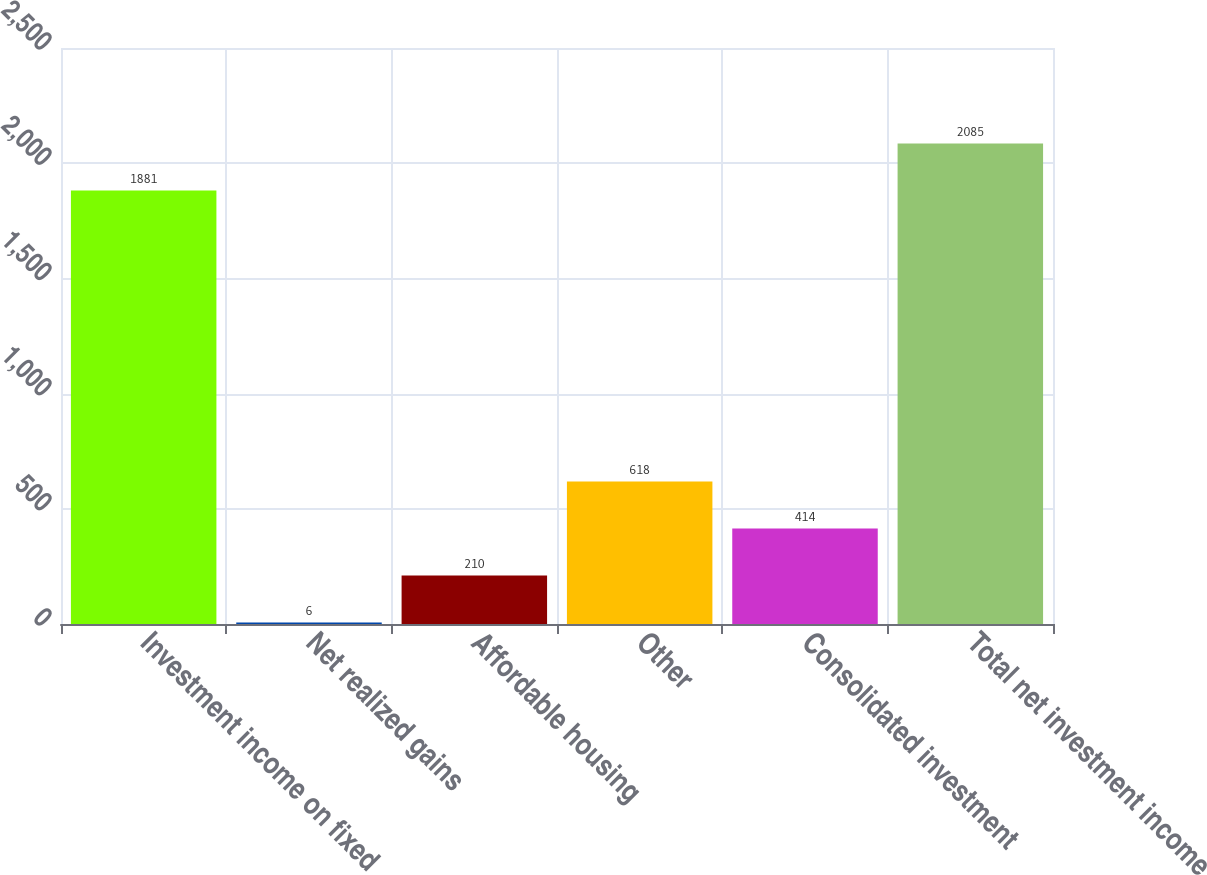Convert chart. <chart><loc_0><loc_0><loc_500><loc_500><bar_chart><fcel>Investment income on fixed<fcel>Net realized gains<fcel>Affordable housing<fcel>Other<fcel>Consolidated investment<fcel>Total net investment income<nl><fcel>1881<fcel>6<fcel>210<fcel>618<fcel>414<fcel>2085<nl></chart> 